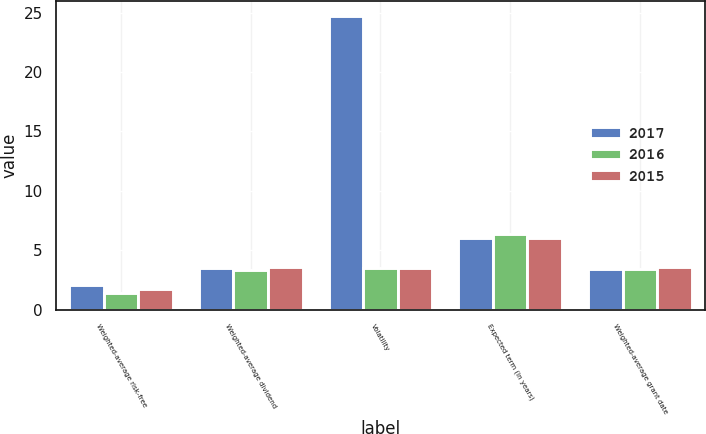Convert chart to OTSL. <chart><loc_0><loc_0><loc_500><loc_500><stacked_bar_chart><ecel><fcel>Weighted-average risk-free<fcel>Weighted-average dividend<fcel>Volatility<fcel>Expected term (in years)<fcel>Weighted-average grant date<nl><fcel>2017<fcel>2.1<fcel>3.5<fcel>24.7<fcel>6.05<fcel>3.39<nl><fcel>2016<fcel>1.4<fcel>3.3<fcel>3.5<fcel>6.32<fcel>3.44<nl><fcel>2015<fcel>1.7<fcel>3.6<fcel>3.5<fcel>6<fcel>3.58<nl></chart> 